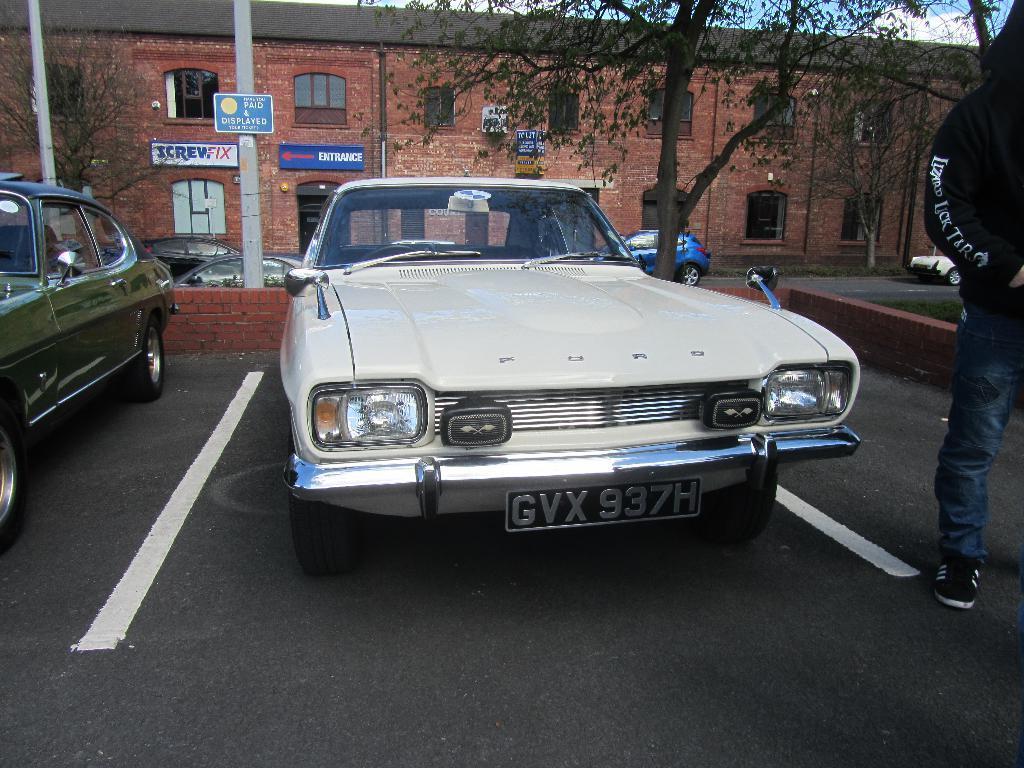Please provide a concise description of this image. In this image there is a white color car on the road. Behind it there is a wall. Behind the wall there are few poles. There is a pole having a board attached to it. Few vehicles are on the road. Right side there is a person wearing a black jacket is standing on the road. There are few trees. Behind there is building. Top of it there is sky. 